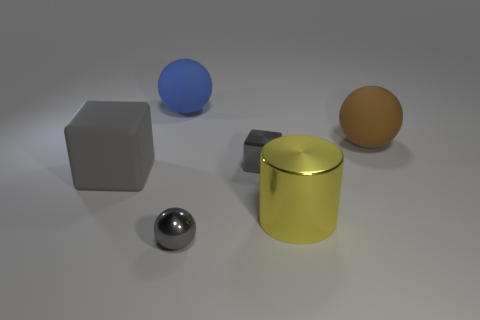What shape is the tiny metal object in front of the tiny gray metal thing behind the big gray object?
Your response must be concise. Sphere. Do the big cube and the metal cylinder have the same color?
Your response must be concise. No. Is the number of blue objects that are in front of the brown thing greater than the number of purple matte cubes?
Provide a short and direct response. No. There is a gray shiny object that is in front of the big yellow metal cylinder; what number of metallic objects are behind it?
Your response must be concise. 2. Are the thing that is to the right of the yellow metallic thing and the gray object on the left side of the blue matte ball made of the same material?
Give a very brief answer. Yes. What is the material of the tiny object that is the same color as the metallic ball?
Your answer should be compact. Metal. How many other things are the same shape as the brown matte thing?
Offer a terse response. 2. Is the big yellow object made of the same material as the gray thing in front of the large yellow metallic cylinder?
Give a very brief answer. Yes. What material is the brown object that is the same size as the yellow thing?
Your response must be concise. Rubber. Are there any blue spheres that have the same size as the blue object?
Offer a very short reply. No. 